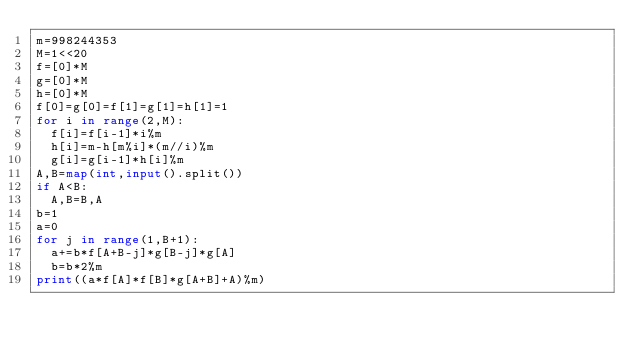Convert code to text. <code><loc_0><loc_0><loc_500><loc_500><_Python_>m=998244353
M=1<<20
f=[0]*M
g=[0]*M
h=[0]*M
f[0]=g[0]=f[1]=g[1]=h[1]=1
for i in range(2,M):
	f[i]=f[i-1]*i%m
	h[i]=m-h[m%i]*(m//i)%m
	g[i]=g[i-1]*h[i]%m
A,B=map(int,input().split())
if A<B:
	A,B=B,A
b=1
a=0
for j in range(1,B+1):
	a+=b*f[A+B-j]*g[B-j]*g[A]
	b=b*2%m
print((a*f[A]*f[B]*g[A+B]+A)%m)</code> 